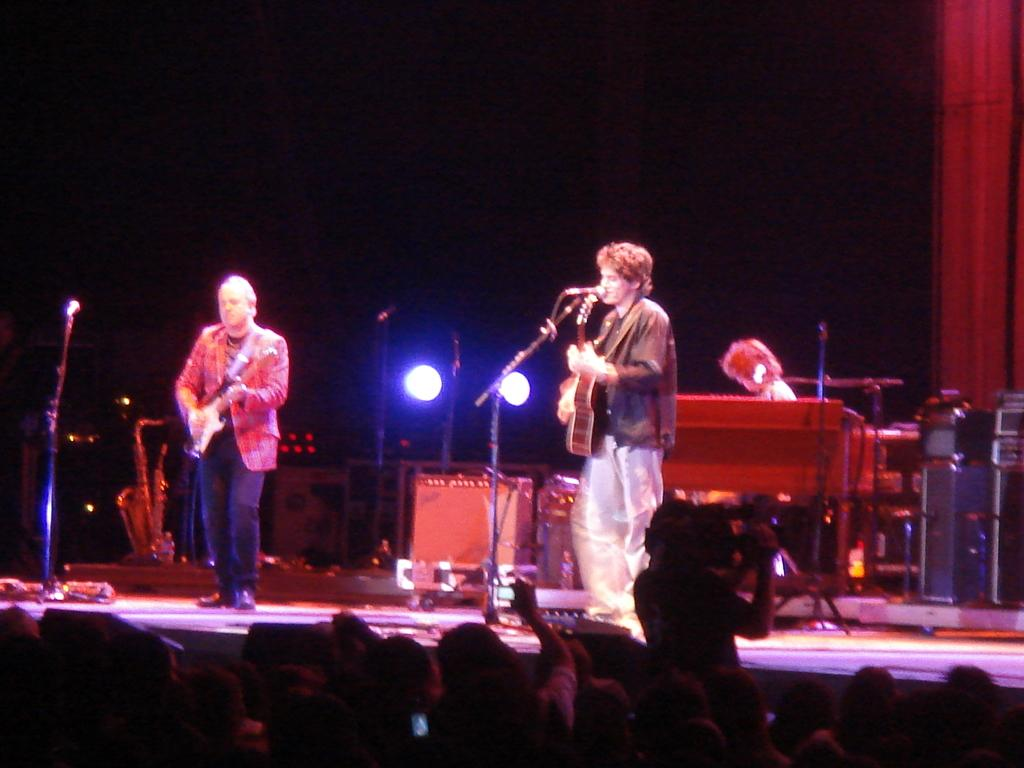What are the persons on the stage doing? The persons on the stage are playing musical instruments. Can you describe any specific lighting in the image? There is a focusing light visible in the image. Who else is present in the image besides the musicians on stage? There is an audience present in the image. What type of soup is being served to the audience in the image? There is no soup present in the image; it features musicians playing on a stage with an audience. What type of blade is being used by the musicians on stage? There is no blade present in the image; the musicians are playing musical instruments. 